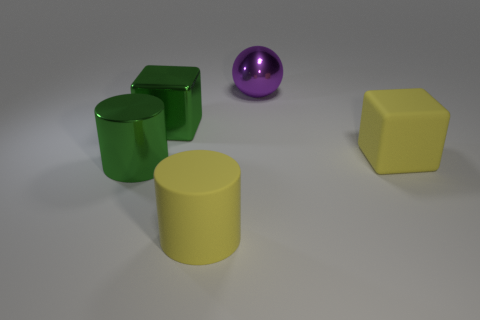What number of big objects are either green shiny blocks or blue matte cylinders?
Give a very brief answer. 1. What material is the object that is both behind the large metal cylinder and left of the big purple sphere?
Give a very brief answer. Metal. Does the big yellow object that is behind the yellow matte cylinder have the same shape as the big yellow matte thing on the left side of the purple sphere?
Make the answer very short. No. What shape is the big object that is the same color as the matte cube?
Make the answer very short. Cylinder. How many objects are either large things that are behind the large yellow rubber cube or large green shiny cylinders?
Provide a short and direct response. 3. Do the ball and the metal block have the same size?
Provide a short and direct response. Yes. What color is the cylinder on the right side of the big metal cylinder?
Your answer should be very brief. Yellow. What size is the sphere that is made of the same material as the green cylinder?
Your answer should be compact. Large. Is the size of the sphere the same as the yellow thing behind the large green shiny cylinder?
Offer a terse response. Yes. What is the object that is behind the green shiny cube made of?
Provide a succinct answer. Metal. 